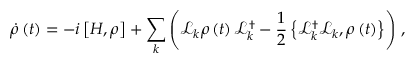<formula> <loc_0><loc_0><loc_500><loc_500>\dot { \rho } \left ( t \right ) = - i \left [ H , \rho \right ] + \sum _ { k } \left ( \mathcal { L } _ { k } \rho \left ( t \right ) \mathcal { L } _ { k } ^ { \dagger } - \frac { 1 } { 2 } \left \{ \mathcal { L } _ { k } ^ { \dagger } \mathcal { L } _ { k } , \rho \left ( t \right ) \right \} \right ) \, ,</formula> 